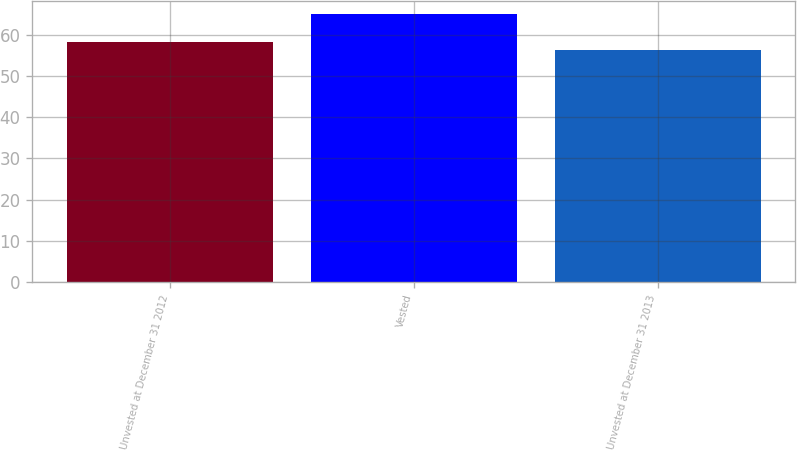<chart> <loc_0><loc_0><loc_500><loc_500><bar_chart><fcel>Unvested at December 31 2012<fcel>Vested<fcel>Unvested at December 31 2013<nl><fcel>58.25<fcel>65.1<fcel>56.25<nl></chart> 